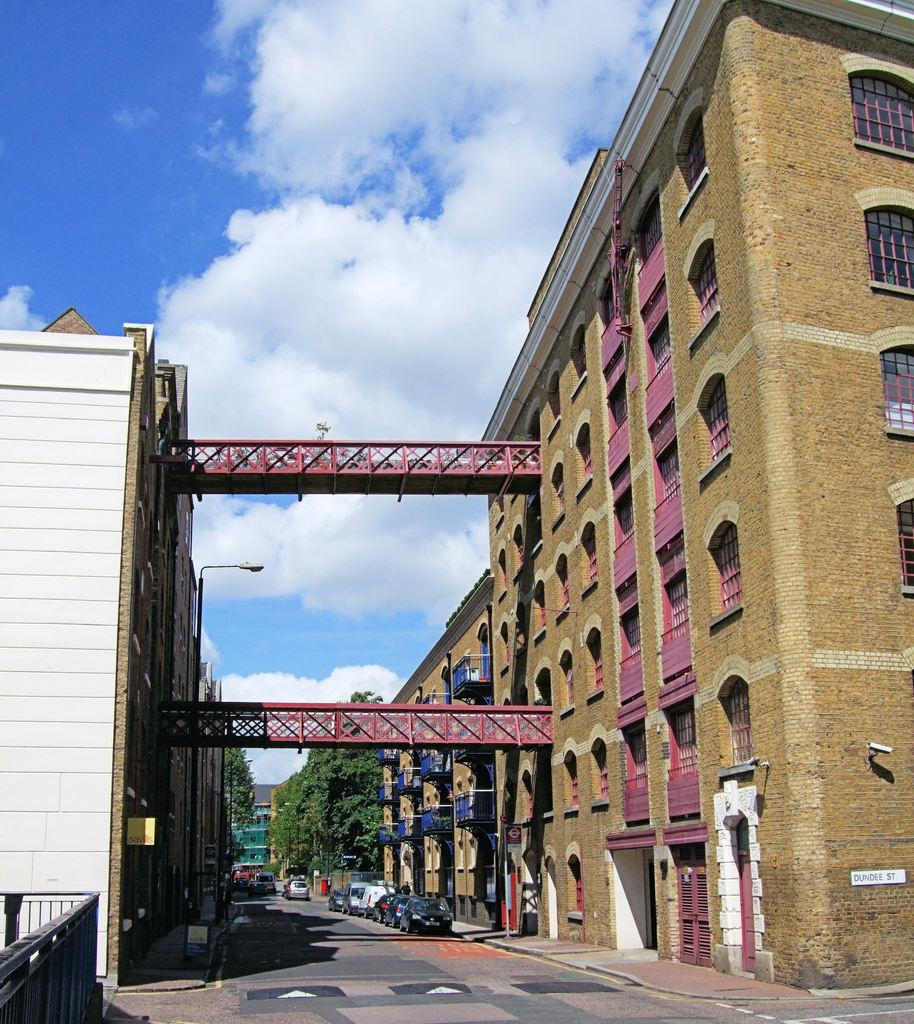What is the main subject of the image? The main subject of the image is a road. What can be seen on the road? There are cars parked on the road. What is visible on either side of the road? There are buildings on either side of the road. How would you describe the weather in the image? The sky is cloudy in the image, suggesting a potentially overcast or cloudy day. What type of unit is being measured with chalk on the road in the image? There is no unit being measured with chalk on the road in the image. What tax is being collected from the cars parked on the road in the image? There is no indication of any tax being collected from the cars parked on the road in the image. 